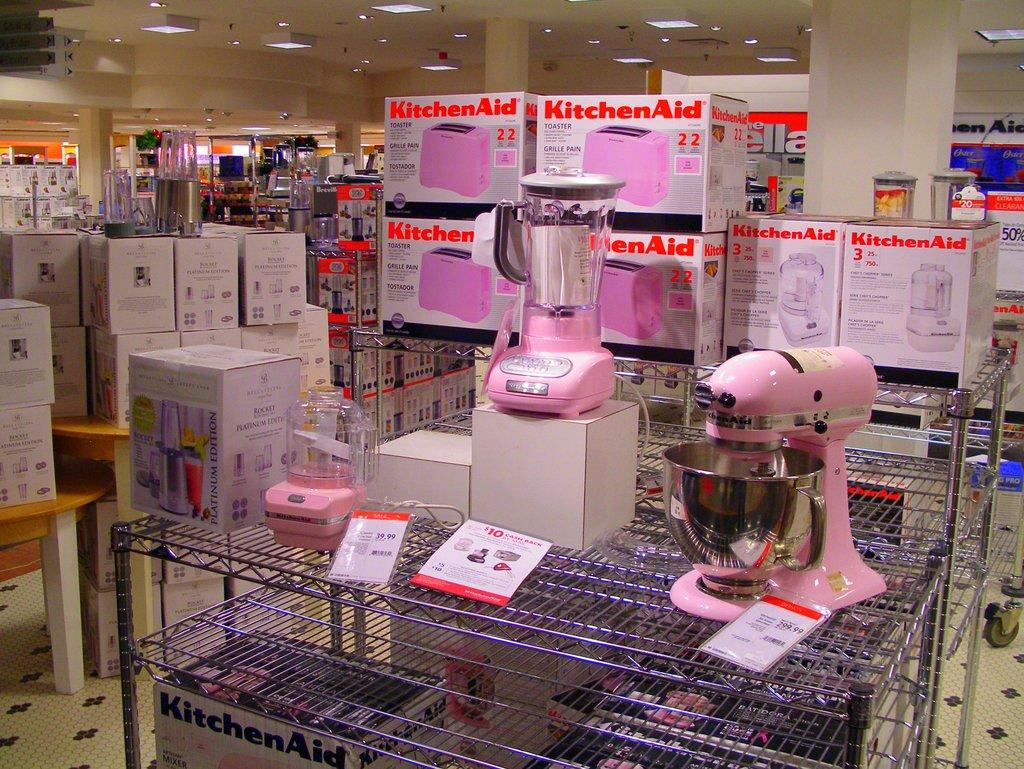<image>
Provide a brief description of the given image. A group of products by the brand KitchinAid. 